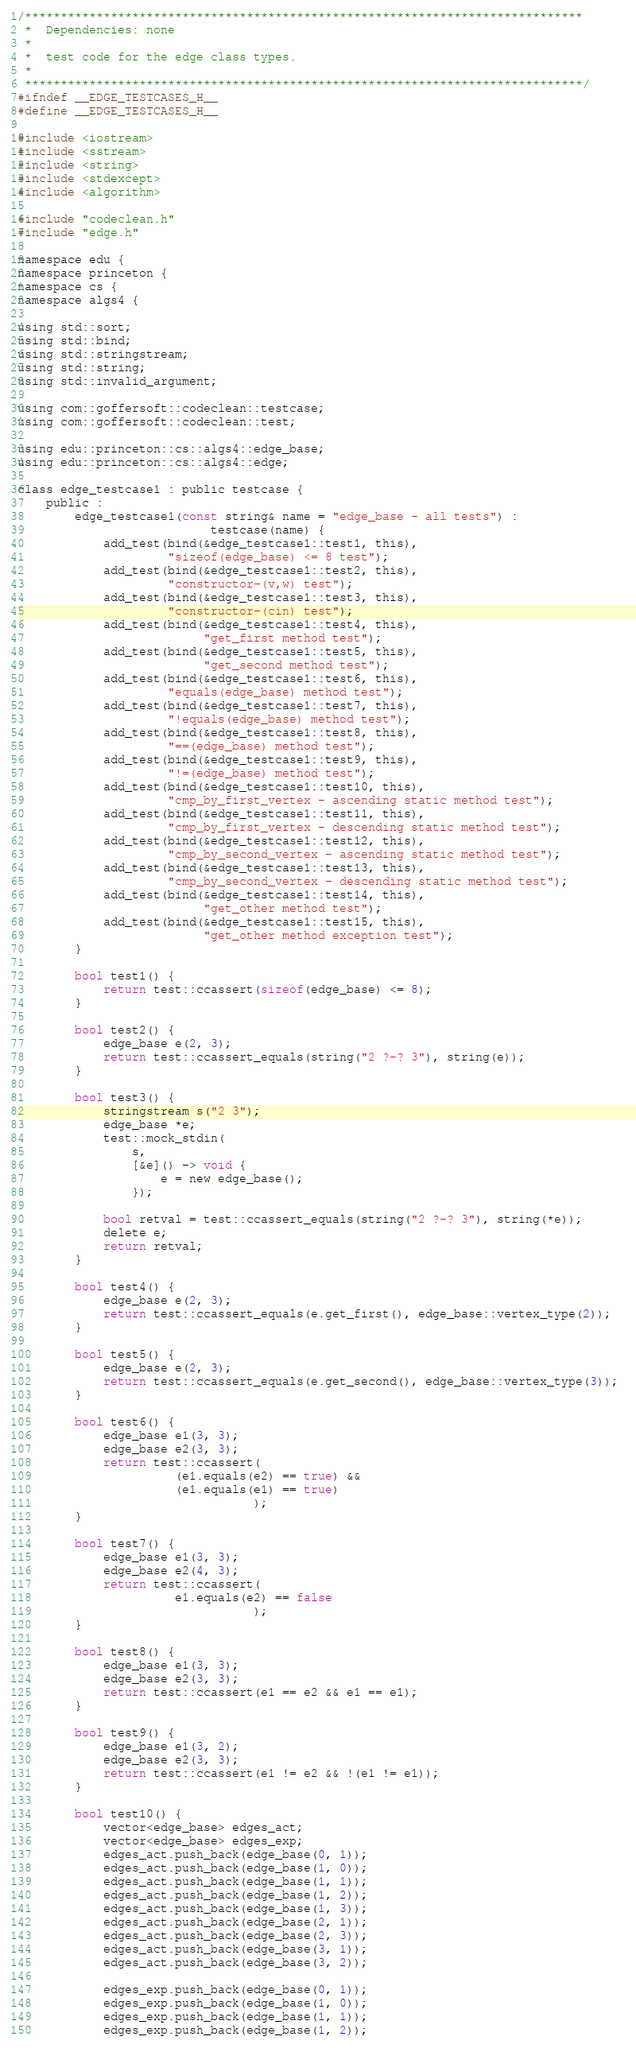Convert code to text. <code><loc_0><loc_0><loc_500><loc_500><_C_>/******************************************************************************
 *  Dependencies: none
 *
 *  test code for the edge class types.
 *
 ******************************************************************************/
#ifndef __EDGE_TESTCASES_H__
#define __EDGE_TESTCASES_H__

#include <iostream>
#include <sstream>
#include <string>
#include <stdexcept>
#include <algorithm>

#include "codeclean.h"
#include "edge.h"

namespace edu {
namespace princeton {
namespace cs {
namespace algs4 {

using std::sort;
using std::bind;
using std::stringstream;
using std::string;
using std::invalid_argument;

using com::goffersoft::codeclean::testcase;
using com::goffersoft::codeclean::test;

using edu::princeton::cs::algs4::edge_base;
using edu::princeton::cs::algs4::edge;

class edge_testcase1 : public testcase {
    public :
        edge_testcase1(const string& name = "edge_base - all tests") :
                           testcase(name) {
            add_test(bind(&edge_testcase1::test1, this),
                     "sizeof(edge_base) <= 8 test");
            add_test(bind(&edge_testcase1::test2, this),
                     "constructor-(v,w) test");
            add_test(bind(&edge_testcase1::test3, this),
                     "constructor-(cin) test");
            add_test(bind(&edge_testcase1::test4, this),
                          "get_first method test");
            add_test(bind(&edge_testcase1::test5, this),
                          "get_second method test");
            add_test(bind(&edge_testcase1::test6, this),
                     "equals(edge_base) method test");
            add_test(bind(&edge_testcase1::test7, this),
                     "!equals(edge_base) method test");
            add_test(bind(&edge_testcase1::test8, this),
                     "==(edge_base) method test");
            add_test(bind(&edge_testcase1::test9, this),
                     "!=(edge_base) method test");
            add_test(bind(&edge_testcase1::test10, this),
                     "cmp_by_first_vertex - ascending static method test");
            add_test(bind(&edge_testcase1::test11, this),
                     "cmp_by_first_vertex - descending static method test");
            add_test(bind(&edge_testcase1::test12, this),
                     "cmp_by_second_vertex - ascending static method test");
            add_test(bind(&edge_testcase1::test13, this),
                     "cmp_by_second_vertex - descending static method test");
            add_test(bind(&edge_testcase1::test14, this),
                          "get_other method test");
            add_test(bind(&edge_testcase1::test15, this),
                          "get_other method exception test");
        }

        bool test1() {
            return test::ccassert(sizeof(edge_base) <= 8);
        }

        bool test2() {
            edge_base e(2, 3);
            return test::ccassert_equals(string("2 ?-? 3"), string(e)); 
        }

        bool test3() {
            stringstream s("2 3");
            edge_base *e;
            test::mock_stdin(
                s,
                [&e]() -> void {
                    e = new edge_base();
                });
             
            bool retval = test::ccassert_equals(string("2 ?-? 3"), string(*e)); 
            delete e;
            return retval;
        }

        bool test4() {
            edge_base e(2, 3);
            return test::ccassert_equals(e.get_first(), edge_base::vertex_type(2)); 
        }

        bool test5() {
            edge_base e(2, 3);
            return test::ccassert_equals(e.get_second(), edge_base::vertex_type(3)); 
        }

        bool test6() {
            edge_base e1(3, 3);
            edge_base e2(3, 3);
            return test::ccassert(
                      (e1.equals(e2) == true) &&
                      (e1.equals(e1) == true)
                                 );
        }

        bool test7() {
            edge_base e1(3, 3);
            edge_base e2(4, 3);
            return test::ccassert(
                      e1.equals(e2) == false
                                 );
        }

        bool test8() {
            edge_base e1(3, 3);
            edge_base e2(3, 3);
            return test::ccassert(e1 == e2 && e1 == e1);
        }

        bool test9() {
            edge_base e1(3, 2);
            edge_base e2(3, 3);
            return test::ccassert(e1 != e2 && !(e1 != e1));
        }

        bool test10() {
            vector<edge_base> edges_act;
            vector<edge_base> edges_exp;
            edges_act.push_back(edge_base(0, 1));
            edges_act.push_back(edge_base(1, 0));
            edges_act.push_back(edge_base(1, 1));
            edges_act.push_back(edge_base(1, 2));
            edges_act.push_back(edge_base(1, 3));
            edges_act.push_back(edge_base(2, 1));
            edges_act.push_back(edge_base(2, 3));
            edges_act.push_back(edge_base(3, 1));
            edges_act.push_back(edge_base(3, 2));

            edges_exp.push_back(edge_base(0, 1));
            edges_exp.push_back(edge_base(1, 0));
            edges_exp.push_back(edge_base(1, 1));
            edges_exp.push_back(edge_base(1, 2));</code> 